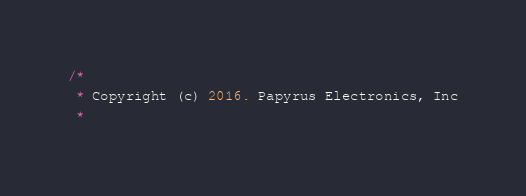<code> <loc_0><loc_0><loc_500><loc_500><_Java_>/*
 * Copyright (c) 2016. Papyrus Electronics, Inc
 *</code> 